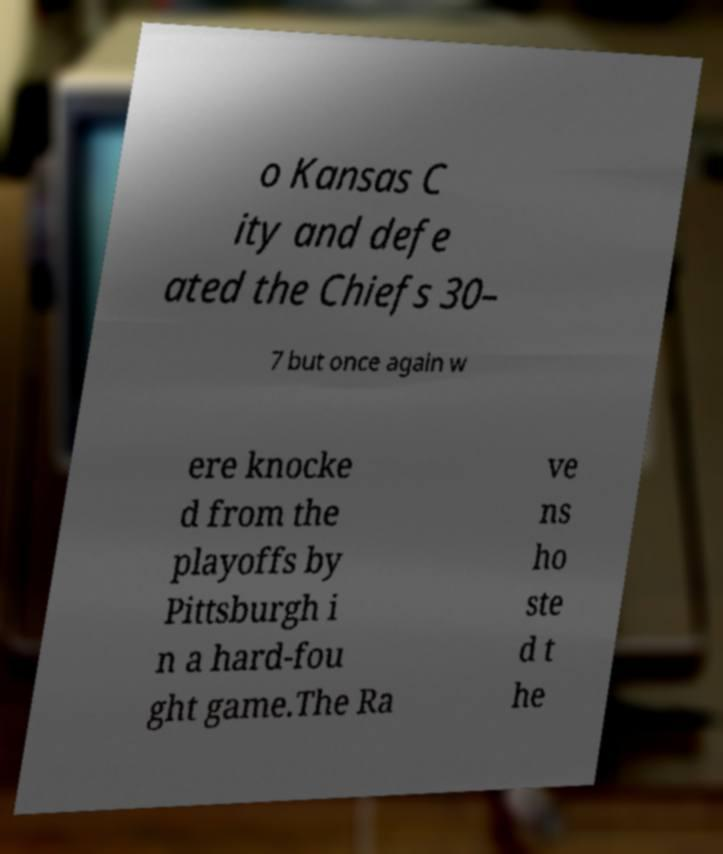Can you read and provide the text displayed in the image?This photo seems to have some interesting text. Can you extract and type it out for me? o Kansas C ity and defe ated the Chiefs 30– 7 but once again w ere knocke d from the playoffs by Pittsburgh i n a hard-fou ght game.The Ra ve ns ho ste d t he 